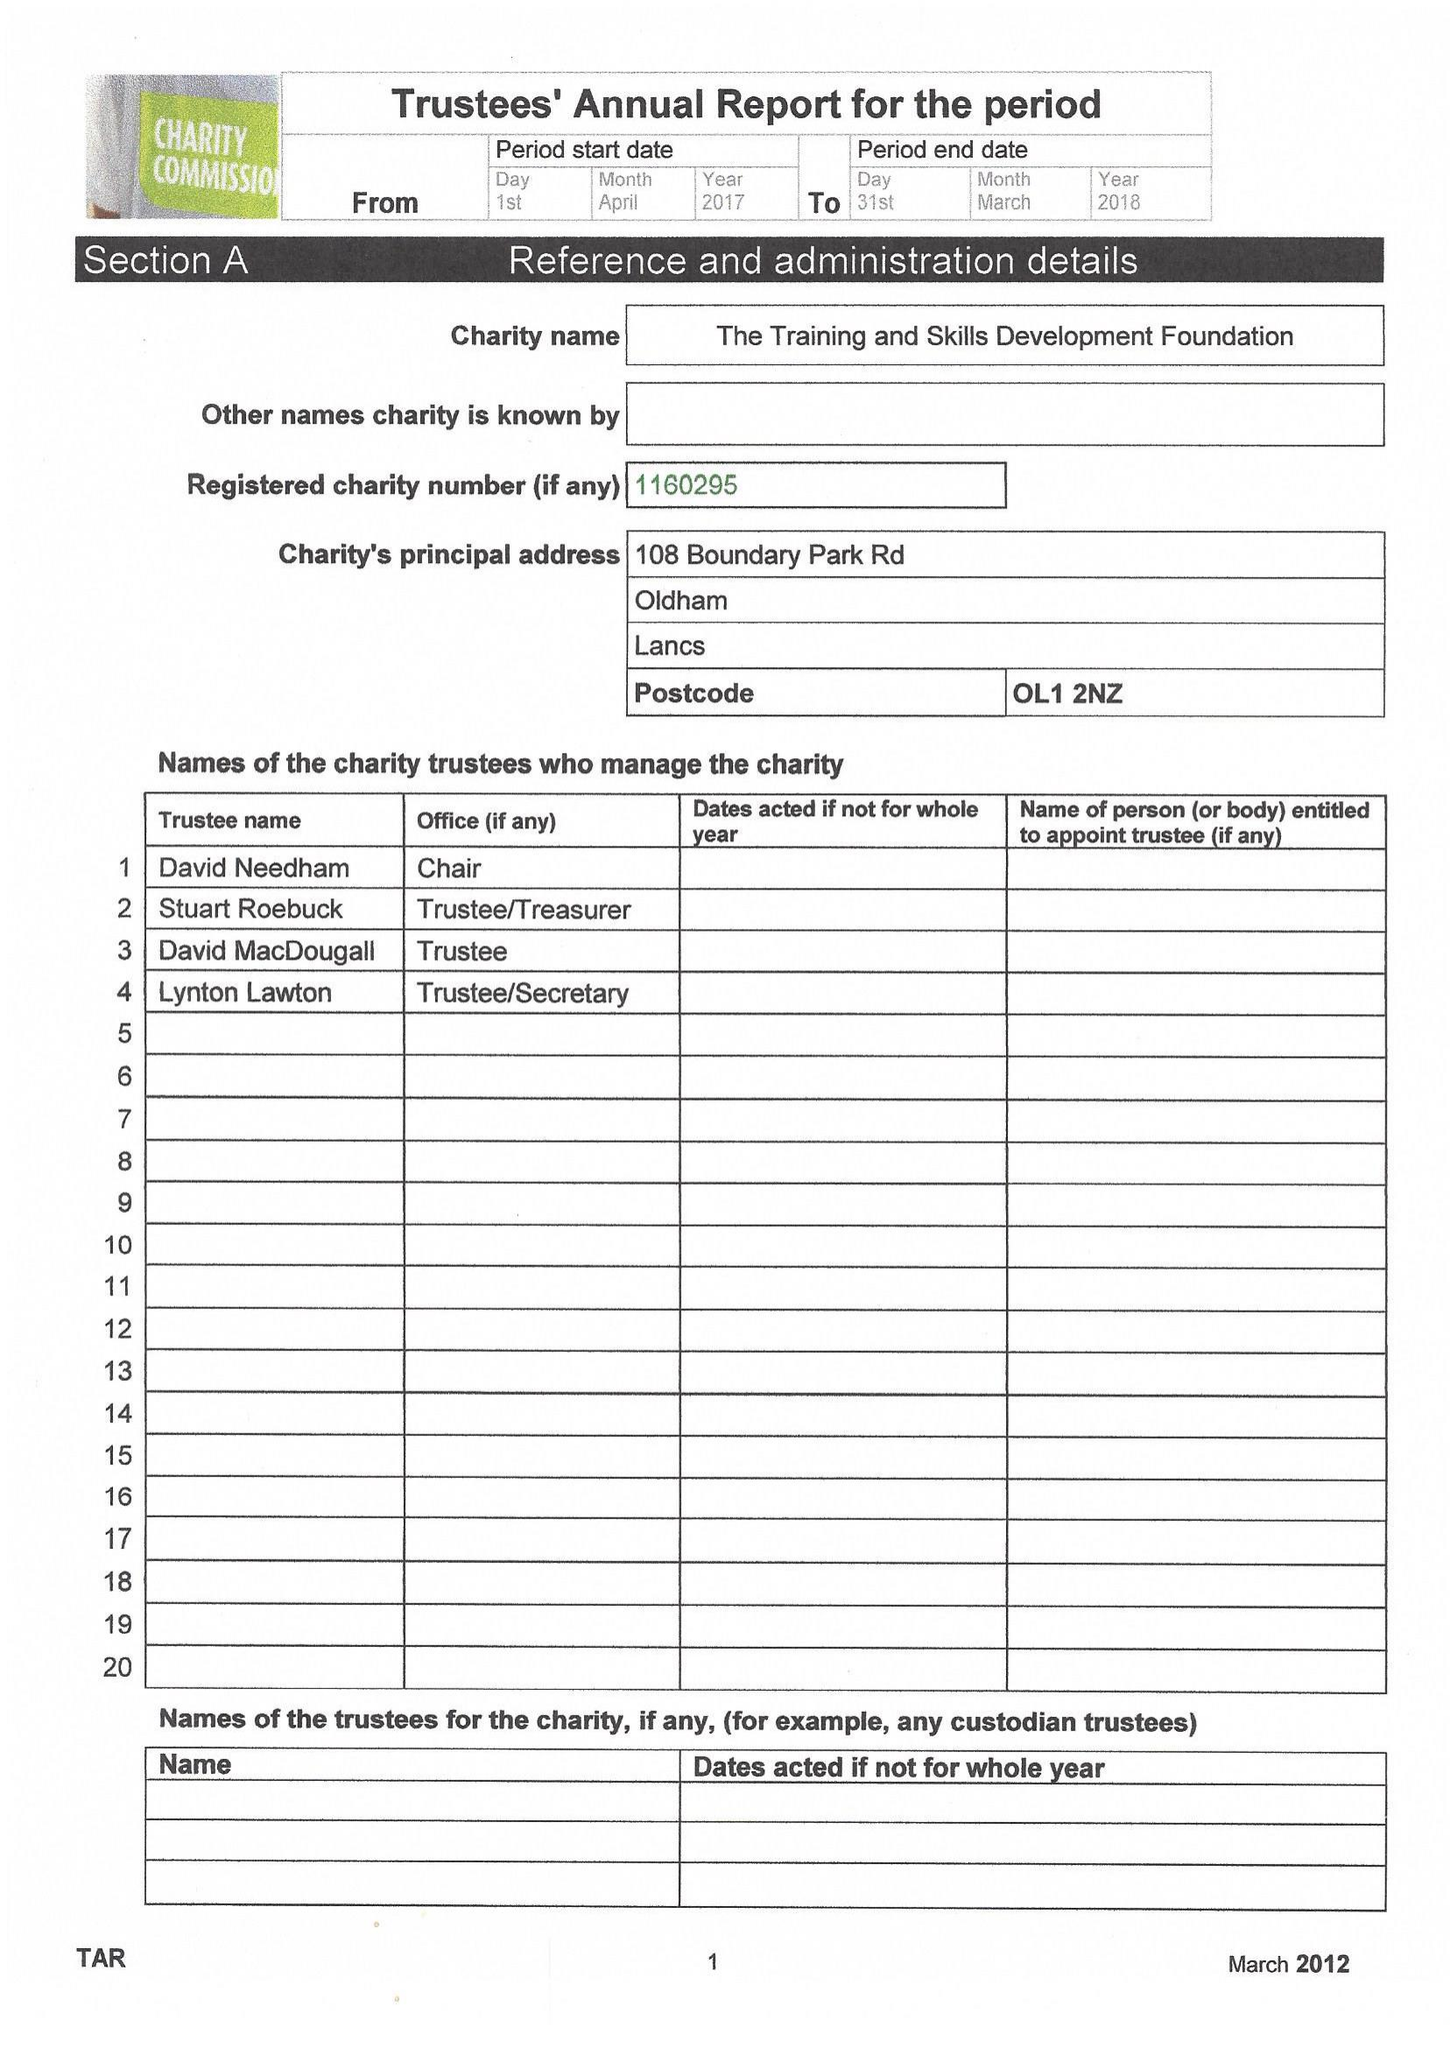What is the value for the spending_annually_in_british_pounds?
Answer the question using a single word or phrase. 13975.00 